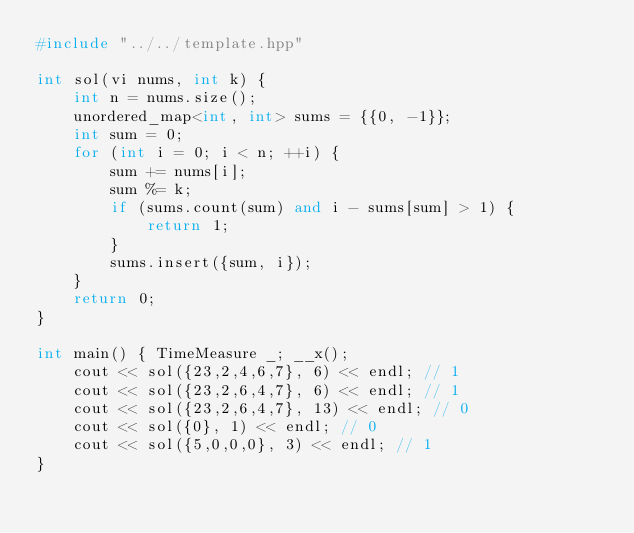<code> <loc_0><loc_0><loc_500><loc_500><_C++_>#include "../../template.hpp"

int sol(vi nums, int k) {
    int n = nums.size();
    unordered_map<int, int> sums = {{0, -1}};
    int sum = 0;
    for (int i = 0; i < n; ++i) {
        sum += nums[i];
        sum %= k;
        if (sums.count(sum) and i - sums[sum] > 1) {
            return 1;
        }
        sums.insert({sum, i});
    }
    return 0;
}

int main() { TimeMeasure _; __x();
    cout << sol({23,2,4,6,7}, 6) << endl; // 1
    cout << sol({23,2,6,4,7}, 6) << endl; // 1
    cout << sol({23,2,6,4,7}, 13) << endl; // 0
    cout << sol({0}, 1) << endl; // 0
    cout << sol({5,0,0,0}, 3) << endl; // 1
}
</code> 